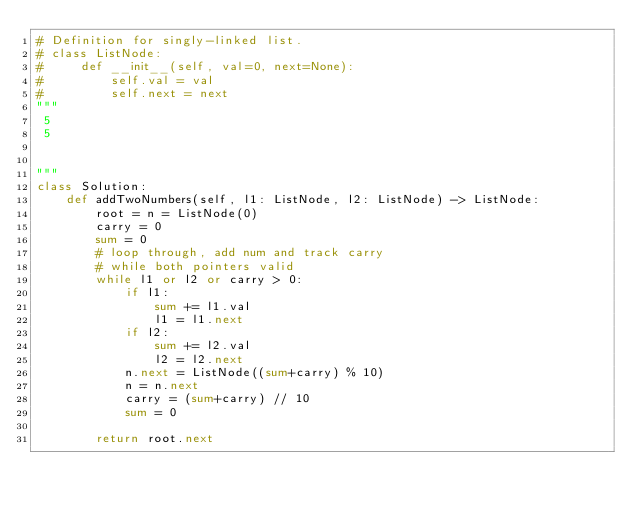<code> <loc_0><loc_0><loc_500><loc_500><_Python_># Definition for singly-linked list.
# class ListNode:
#     def __init__(self, val=0, next=None):
#         self.val = val
#         self.next = next
"""
 5
 5
 
 
"""
class Solution:
    def addTwoNumbers(self, l1: ListNode, l2: ListNode) -> ListNode:
        root = n = ListNode(0)
        carry = 0
        sum = 0
        # loop through, add num and track carry
        # while both pointers valid
        while l1 or l2 or carry > 0:
            if l1:
                sum += l1.val
                l1 = l1.next
            if l2:
                sum += l2.val
                l2 = l2.next
            n.next = ListNode((sum+carry) % 10)
            n = n.next
            carry = (sum+carry) // 10
            sum = 0
          
        return root.next
</code> 